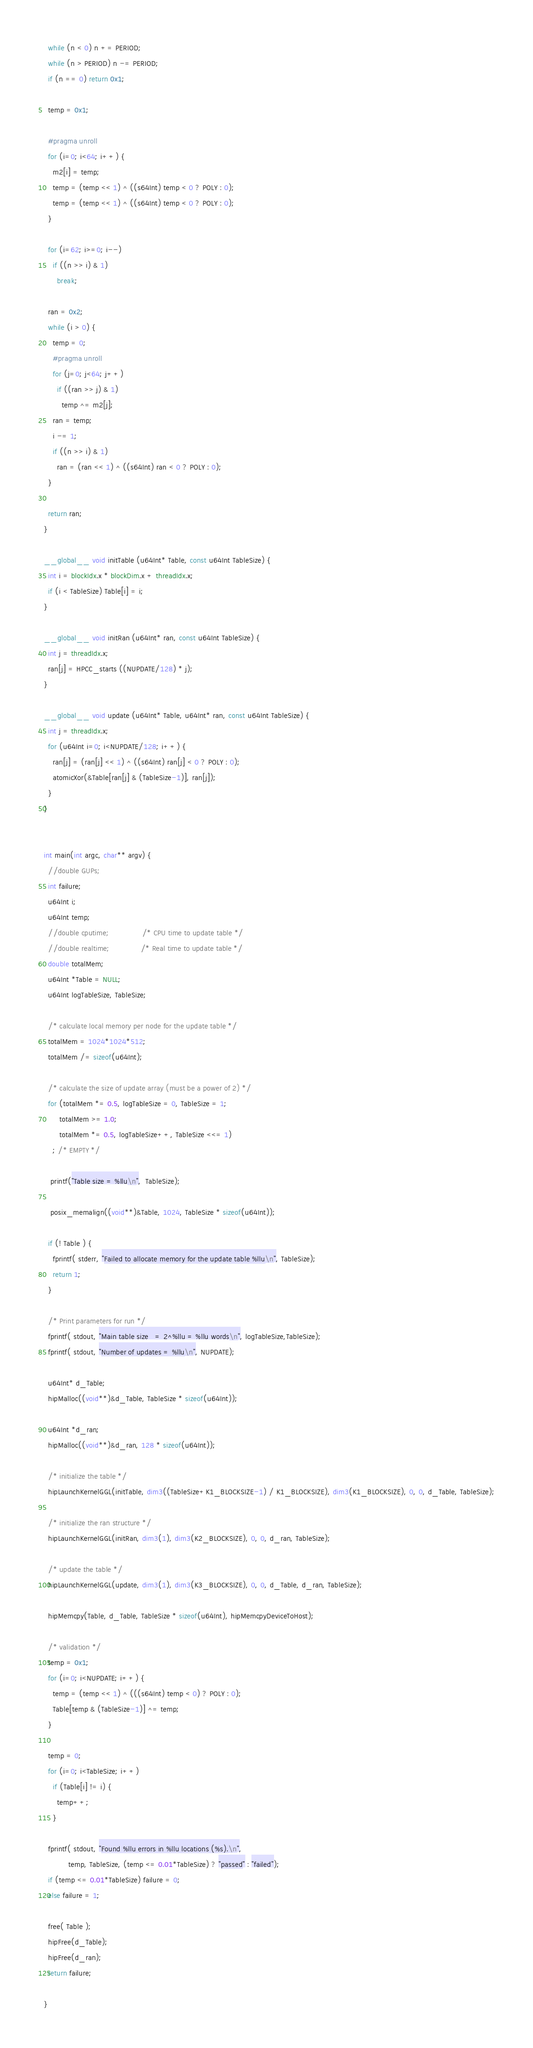<code> <loc_0><loc_0><loc_500><loc_500><_Cuda_>
  while (n < 0) n += PERIOD;
  while (n > PERIOD) n -= PERIOD;
  if (n == 0) return 0x1;

  temp = 0x1;

  #pragma unroll
  for (i=0; i<64; i++) {
    m2[i] = temp;
    temp = (temp << 1) ^ ((s64Int) temp < 0 ? POLY : 0);
    temp = (temp << 1) ^ ((s64Int) temp < 0 ? POLY : 0);
  }

  for (i=62; i>=0; i--)
    if ((n >> i) & 1)
      break;

  ran = 0x2;
  while (i > 0) {
    temp = 0;
    #pragma unroll
    for (j=0; j<64; j++)
      if ((ran >> j) & 1)
        temp ^= m2[j];
    ran = temp;
    i -= 1;
    if ((n >> i) & 1)
      ran = (ran << 1) ^ ((s64Int) ran < 0 ? POLY : 0);
  }

  return ran;
}

__global__ void initTable (u64Int* Table, const u64Int TableSize) {
  int i = blockIdx.x * blockDim.x + threadIdx.x;
  if (i < TableSize) Table[i] = i;
}

__global__ void initRan (u64Int* ran, const u64Int TableSize) {
  int j = threadIdx.x;
  ran[j] = HPCC_starts ((NUPDATE/128) * j);
}

__global__ void update (u64Int* Table, u64Int* ran, const u64Int TableSize) {
  int j = threadIdx.x;
  for (u64Int i=0; i<NUPDATE/128; i++) {
    ran[j] = (ran[j] << 1) ^ ((s64Int) ran[j] < 0 ? POLY : 0);
    atomicXor(&Table[ran[j] & (TableSize-1)], ran[j]);
  }
}


int main(int argc, char** argv) {
  //double GUPs;
  int failure;
  u64Int i;
  u64Int temp;
  //double cputime;               /* CPU time to update table */
  //double realtime;              /* Real time to update table */
  double totalMem;
  u64Int *Table = NULL;
  u64Int logTableSize, TableSize;

  /* calculate local memory per node for the update table */
  totalMem = 1024*1024*512;
  totalMem /= sizeof(u64Int);

  /* calculate the size of update array (must be a power of 2) */
  for (totalMem *= 0.5, logTableSize = 0, TableSize = 1;
       totalMem >= 1.0;
       totalMem *= 0.5, logTableSize++, TableSize <<= 1)
    ; /* EMPTY */

   printf("Table size = %llu\n",  TableSize);

   posix_memalign((void**)&Table, 1024, TableSize * sizeof(u64Int));

  if (! Table ) {
    fprintf( stderr, "Failed to allocate memory for the update table %llu\n", TableSize);
    return 1;
  }

  /* Print parameters for run */
  fprintf( stdout, "Main table size   = 2^%llu = %llu words\n", logTableSize,TableSize);
  fprintf( stdout, "Number of updates = %llu\n", NUPDATE);

  u64Int* d_Table;
  hipMalloc((void**)&d_Table, TableSize * sizeof(u64Int));

  u64Int *d_ran;
  hipMalloc((void**)&d_ran, 128 * sizeof(u64Int));

  /* initialize the table */
  hipLaunchKernelGGL(initTable, dim3((TableSize+K1_BLOCKSIZE-1) / K1_BLOCKSIZE), dim3(K1_BLOCKSIZE), 0, 0, d_Table, TableSize);

  /* initialize the ran structure */
  hipLaunchKernelGGL(initRan, dim3(1), dim3(K2_BLOCKSIZE), 0, 0, d_ran, TableSize);

  /* update the table */
  hipLaunchKernelGGL(update, dim3(1), dim3(K3_BLOCKSIZE), 0, 0, d_Table, d_ran, TableSize);

  hipMemcpy(Table, d_Table, TableSize * sizeof(u64Int), hipMemcpyDeviceToHost);

  /* validation */
  temp = 0x1;
  for (i=0; i<NUPDATE; i++) {
    temp = (temp << 1) ^ (((s64Int) temp < 0) ? POLY : 0);
    Table[temp & (TableSize-1)] ^= temp;
  }
  
  temp = 0;
  for (i=0; i<TableSize; i++)
    if (Table[i] != i) {
      temp++;
    }

  fprintf( stdout, "Found %llu errors in %llu locations (%s).\n",
           temp, TableSize, (temp <= 0.01*TableSize) ? "passed" : "failed");
  if (temp <= 0.01*TableSize) failure = 0;
  else failure = 1;

  free( Table );
  hipFree(d_Table);
  hipFree(d_ran);
  return failure;

}


</code> 